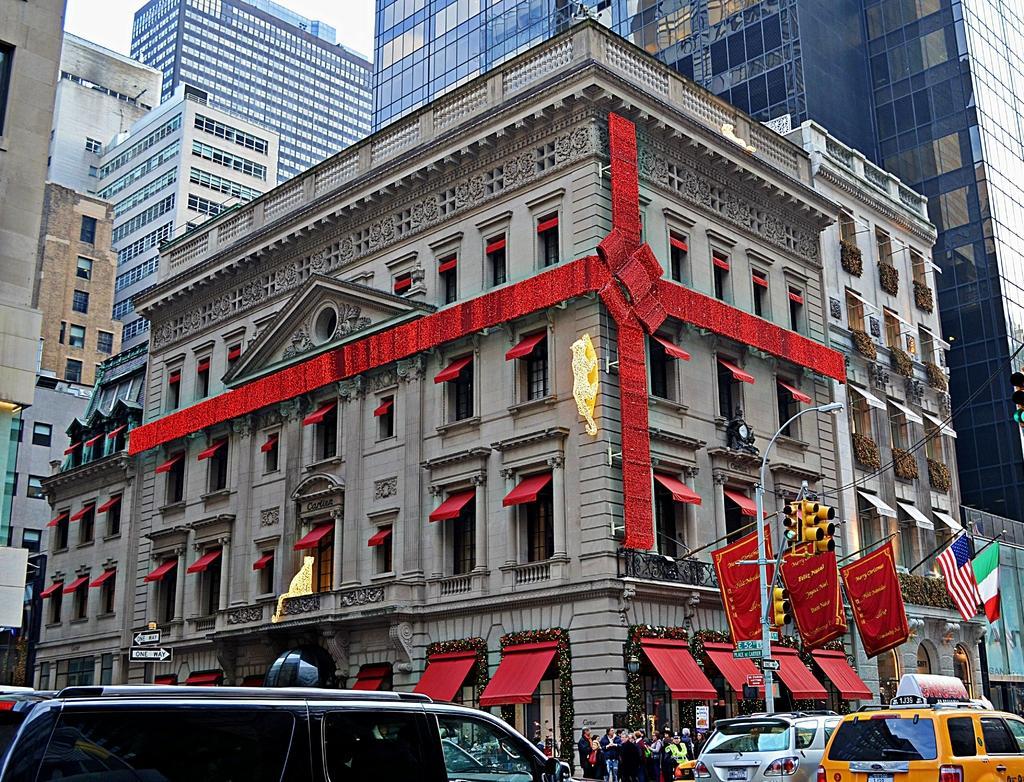How would you summarize this image in a sentence or two? In this image, we can see some buildings. There are vehicles in the bottom left and in the bottom right of the image. There is a crowd at the bottom of the image. There is a signal pole in front of the building. There are flags on the building. 